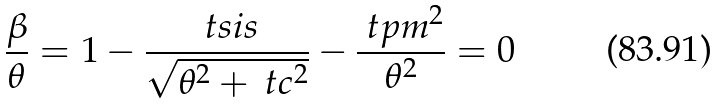Convert formula to latex. <formula><loc_0><loc_0><loc_500><loc_500>\frac { \beta } { \theta } = 1 - \frac { \ t s i s } { \sqrt { \theta ^ { 2 } + \ t c ^ { 2 } } } - \frac { \ t p m ^ { 2 } } { \theta ^ { 2 } } = 0</formula> 